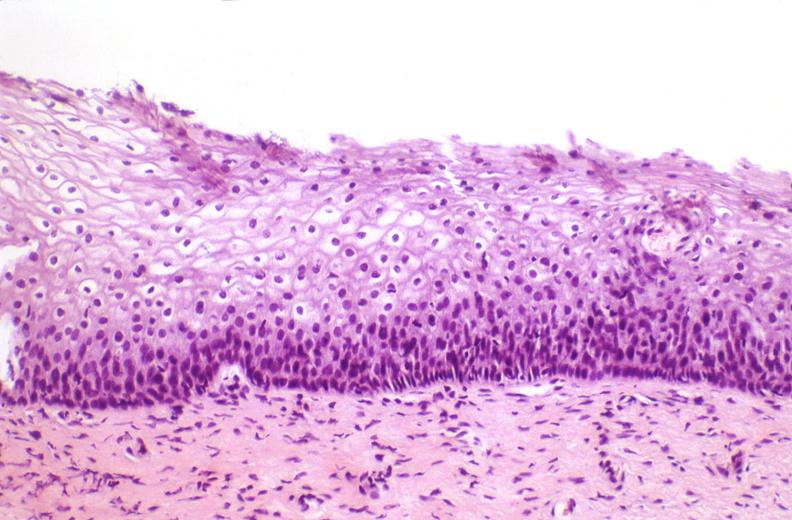where is this from?
Answer the question using a single word or phrase. Female reproductive system 